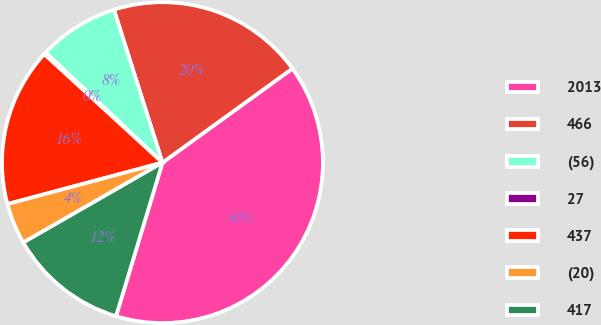Convert chart to OTSL. <chart><loc_0><loc_0><loc_500><loc_500><pie_chart><fcel>2013<fcel>466<fcel>(56)<fcel>27<fcel>437<fcel>(20)<fcel>417<nl><fcel>39.65%<fcel>19.92%<fcel>8.09%<fcel>0.2%<fcel>15.98%<fcel>4.14%<fcel>12.03%<nl></chart> 